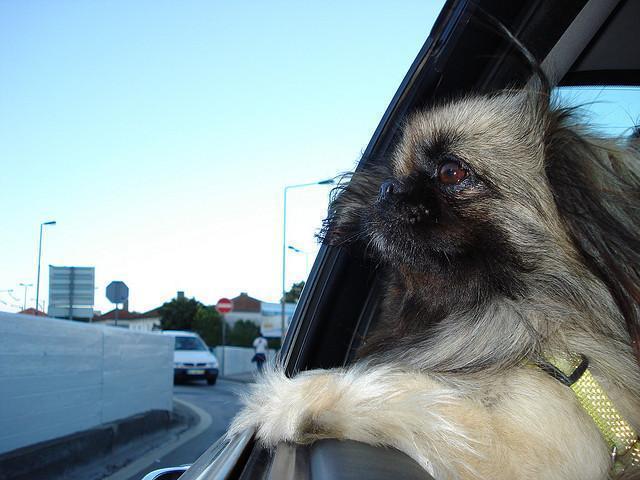What kind of pet is looking out the window?
Indicate the correct response by choosing from the four available options to answer the question.
Options: Cat, rabbit, dog, hamster. Cat. 